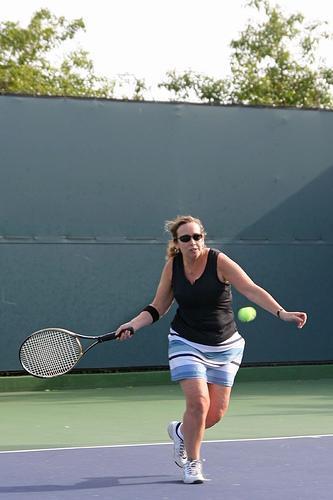How many people are in the photo?
Give a very brief answer. 1. How many tennis balls are blue?
Give a very brief answer. 0. 